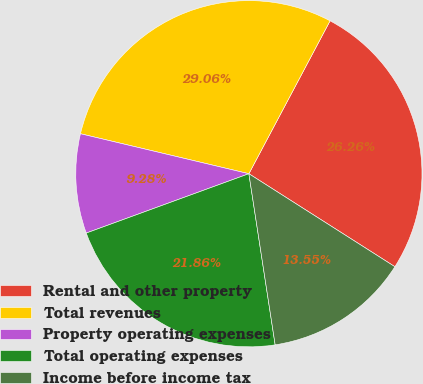<chart> <loc_0><loc_0><loc_500><loc_500><pie_chart><fcel>Rental and other property<fcel>Total revenues<fcel>Property operating expenses<fcel>Total operating expenses<fcel>Income before income tax<nl><fcel>26.26%<fcel>29.06%<fcel>9.28%<fcel>21.86%<fcel>13.55%<nl></chart> 